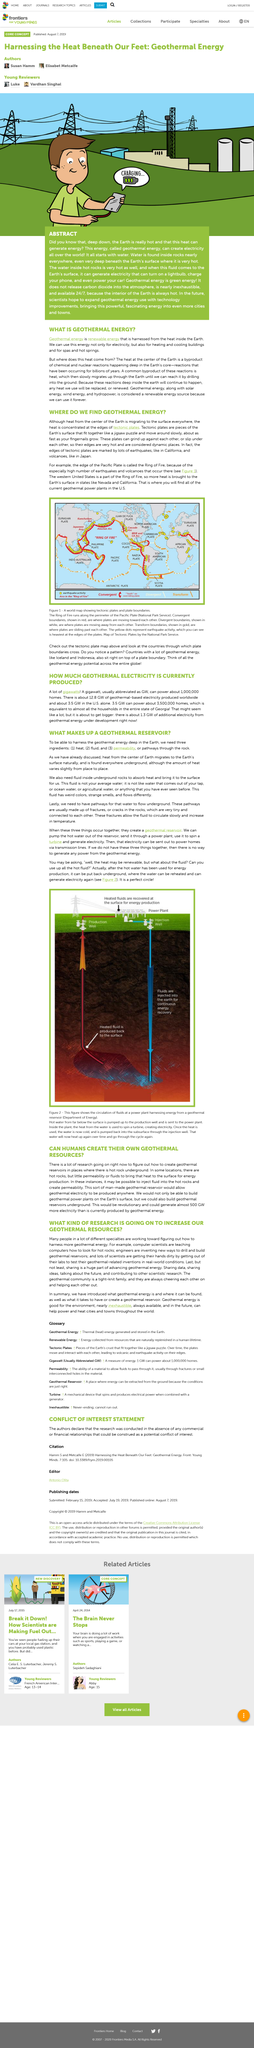Indicate a few pertinent items in this graphic. The use of geothermal energy is beneficial for the environment as it is considered to be environmentally friendly. The article titled "What Kind of Research Is Going On to Increase Our Geothermal Resources?" is a comprehensive examination of the advancements being made in geothermal energy research. This article is about geothermal energy, which is a type of renewable energy that is generated through the use of geothermal resources. The combination of heat, fluid, and permeability is what creates a geothermal reservoir. Figure 1 depicts a world map that displays the tectonic plates and their respective plate boundaries. 